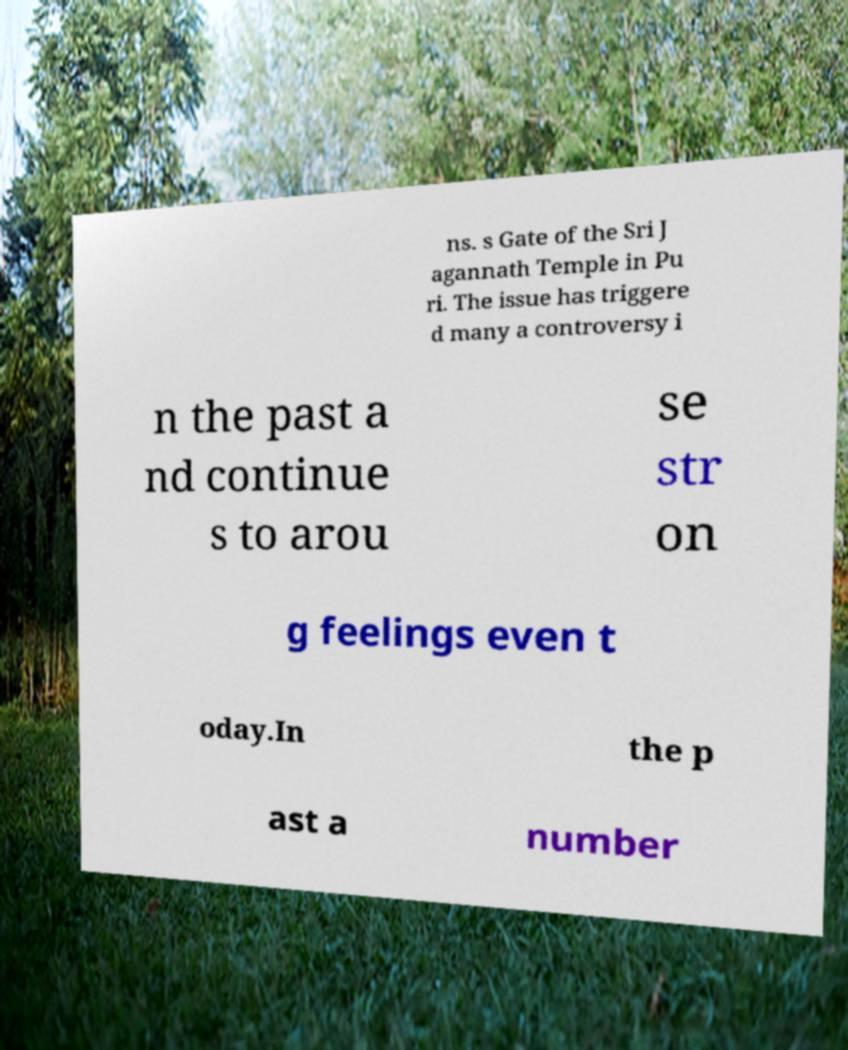There's text embedded in this image that I need extracted. Can you transcribe it verbatim? ns. s Gate of the Sri J agannath Temple in Pu ri. The issue has triggere d many a controversy i n the past a nd continue s to arou se str on g feelings even t oday.In the p ast a number 